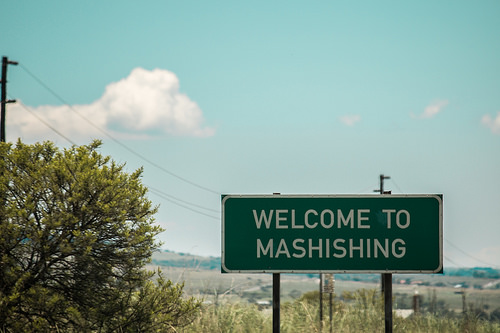<image>
Can you confirm if the cloud is in the sky? Yes. The cloud is contained within or inside the sky, showing a containment relationship. 